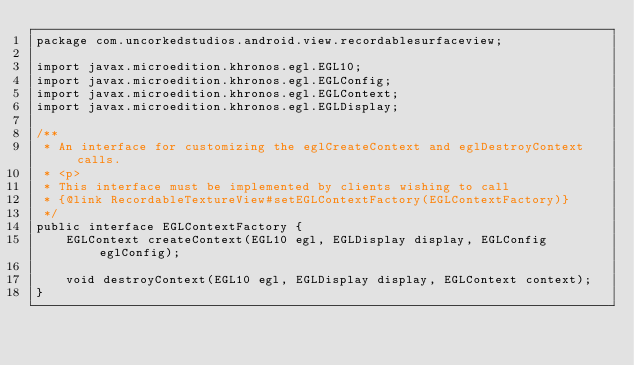Convert code to text. <code><loc_0><loc_0><loc_500><loc_500><_Java_>package com.uncorkedstudios.android.view.recordablesurfaceview;

import javax.microedition.khronos.egl.EGL10;
import javax.microedition.khronos.egl.EGLConfig;
import javax.microedition.khronos.egl.EGLContext;
import javax.microedition.khronos.egl.EGLDisplay;

/**
 * An interface for customizing the eglCreateContext and eglDestroyContext calls.
 * <p>
 * This interface must be implemented by clients wishing to call
 * {@link RecordableTextureView#setEGLContextFactory(EGLContextFactory)}
 */
public interface EGLContextFactory {
    EGLContext createContext(EGL10 egl, EGLDisplay display, EGLConfig eglConfig);

    void destroyContext(EGL10 egl, EGLDisplay display, EGLContext context);
}</code> 